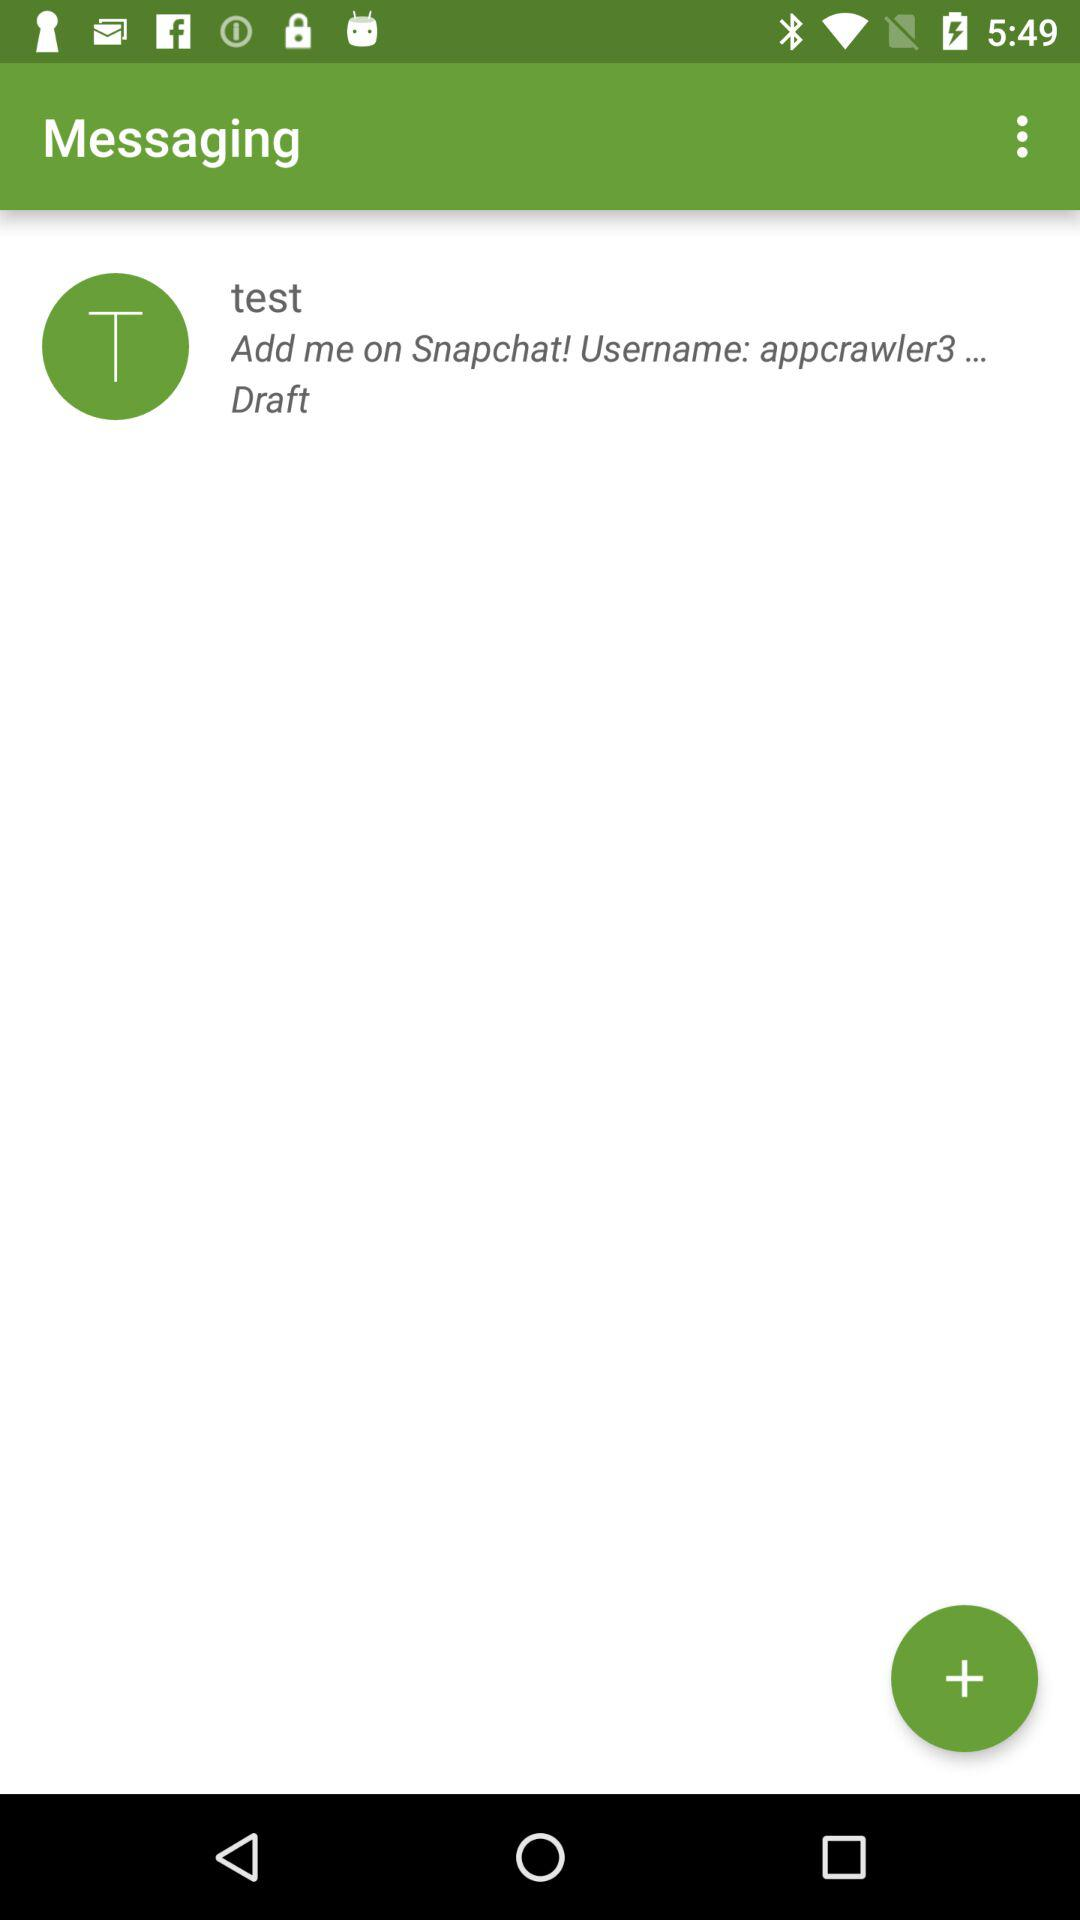What's the message category? The message category is "Draft". 